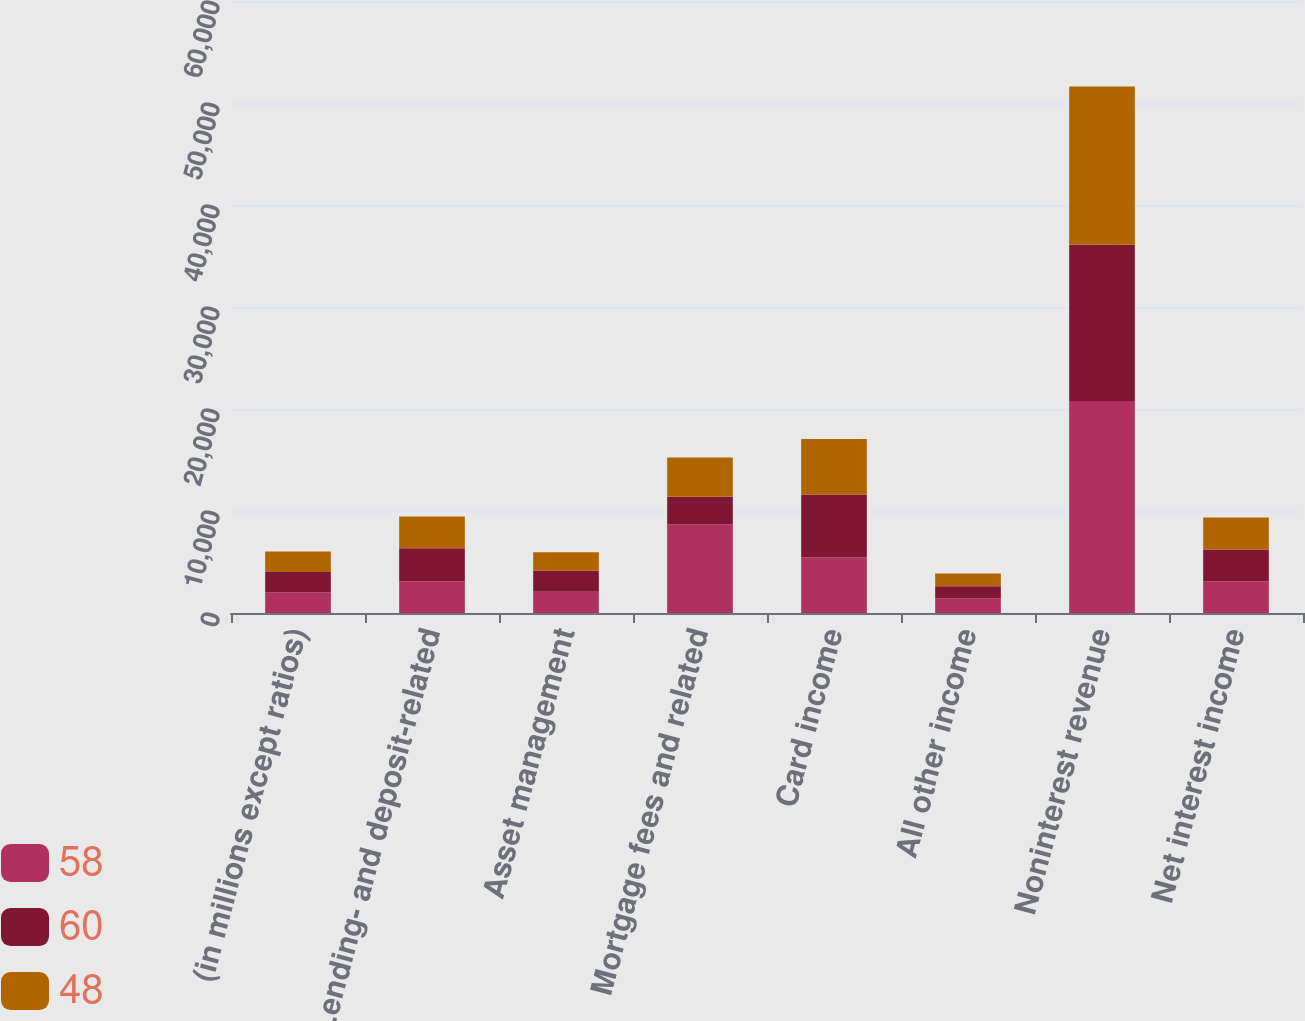<chart> <loc_0><loc_0><loc_500><loc_500><stacked_bar_chart><ecel><fcel>(in millions except ratios)<fcel>Lending- and deposit-related<fcel>Asset management<fcel>Mortgage fees and related<fcel>Card income<fcel>All other income<fcel>Noninterest revenue<fcel>Net interest income<nl><fcel>58<fcel>2012<fcel>3121<fcel>2092<fcel>8680<fcel>5446<fcel>1456<fcel>20795<fcel>3117<nl><fcel>60<fcel>2011<fcel>3219<fcel>2044<fcel>2714<fcel>6152<fcel>1177<fcel>15306<fcel>3117<nl><fcel>48<fcel>2010<fcel>3117<fcel>1831<fcel>3855<fcel>5469<fcel>1241<fcel>15513<fcel>3117<nl></chart> 